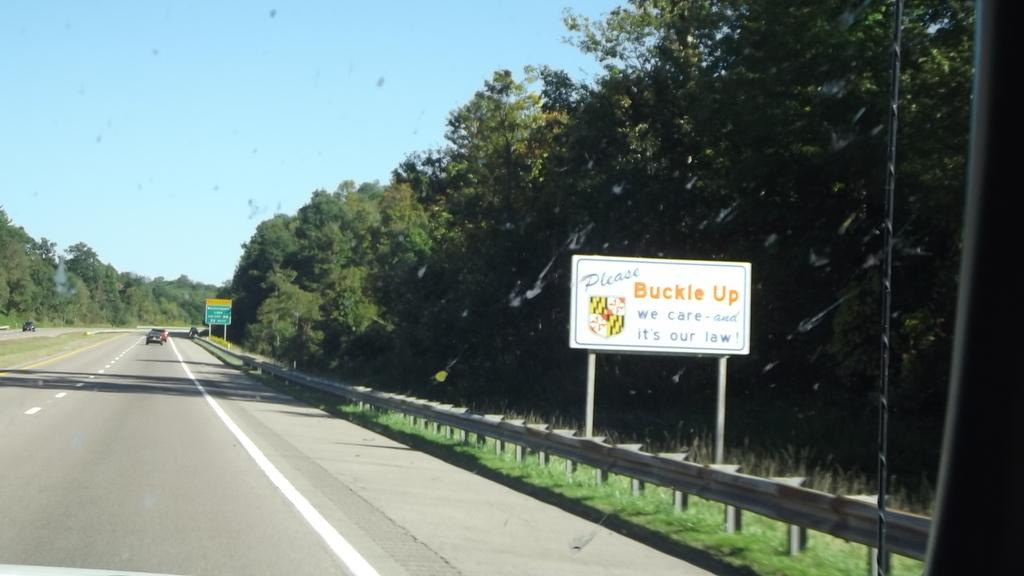What type of vehicles can be seen on the road in the image? There are cars on the road in the image. What objects are visible in the image besides the cars? Boards and poles can be seen in the image. What type of vegetation is present in the image? There is grass and trees in the image. What is visible in the background of the image? The sky is visible in the background of the image. What caption is written on the ocean in the image? There is no ocean present in the image, and therefore no caption can be found on it. 